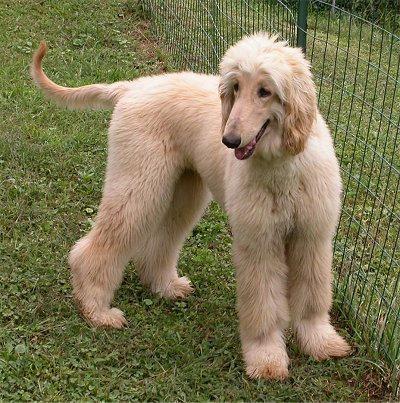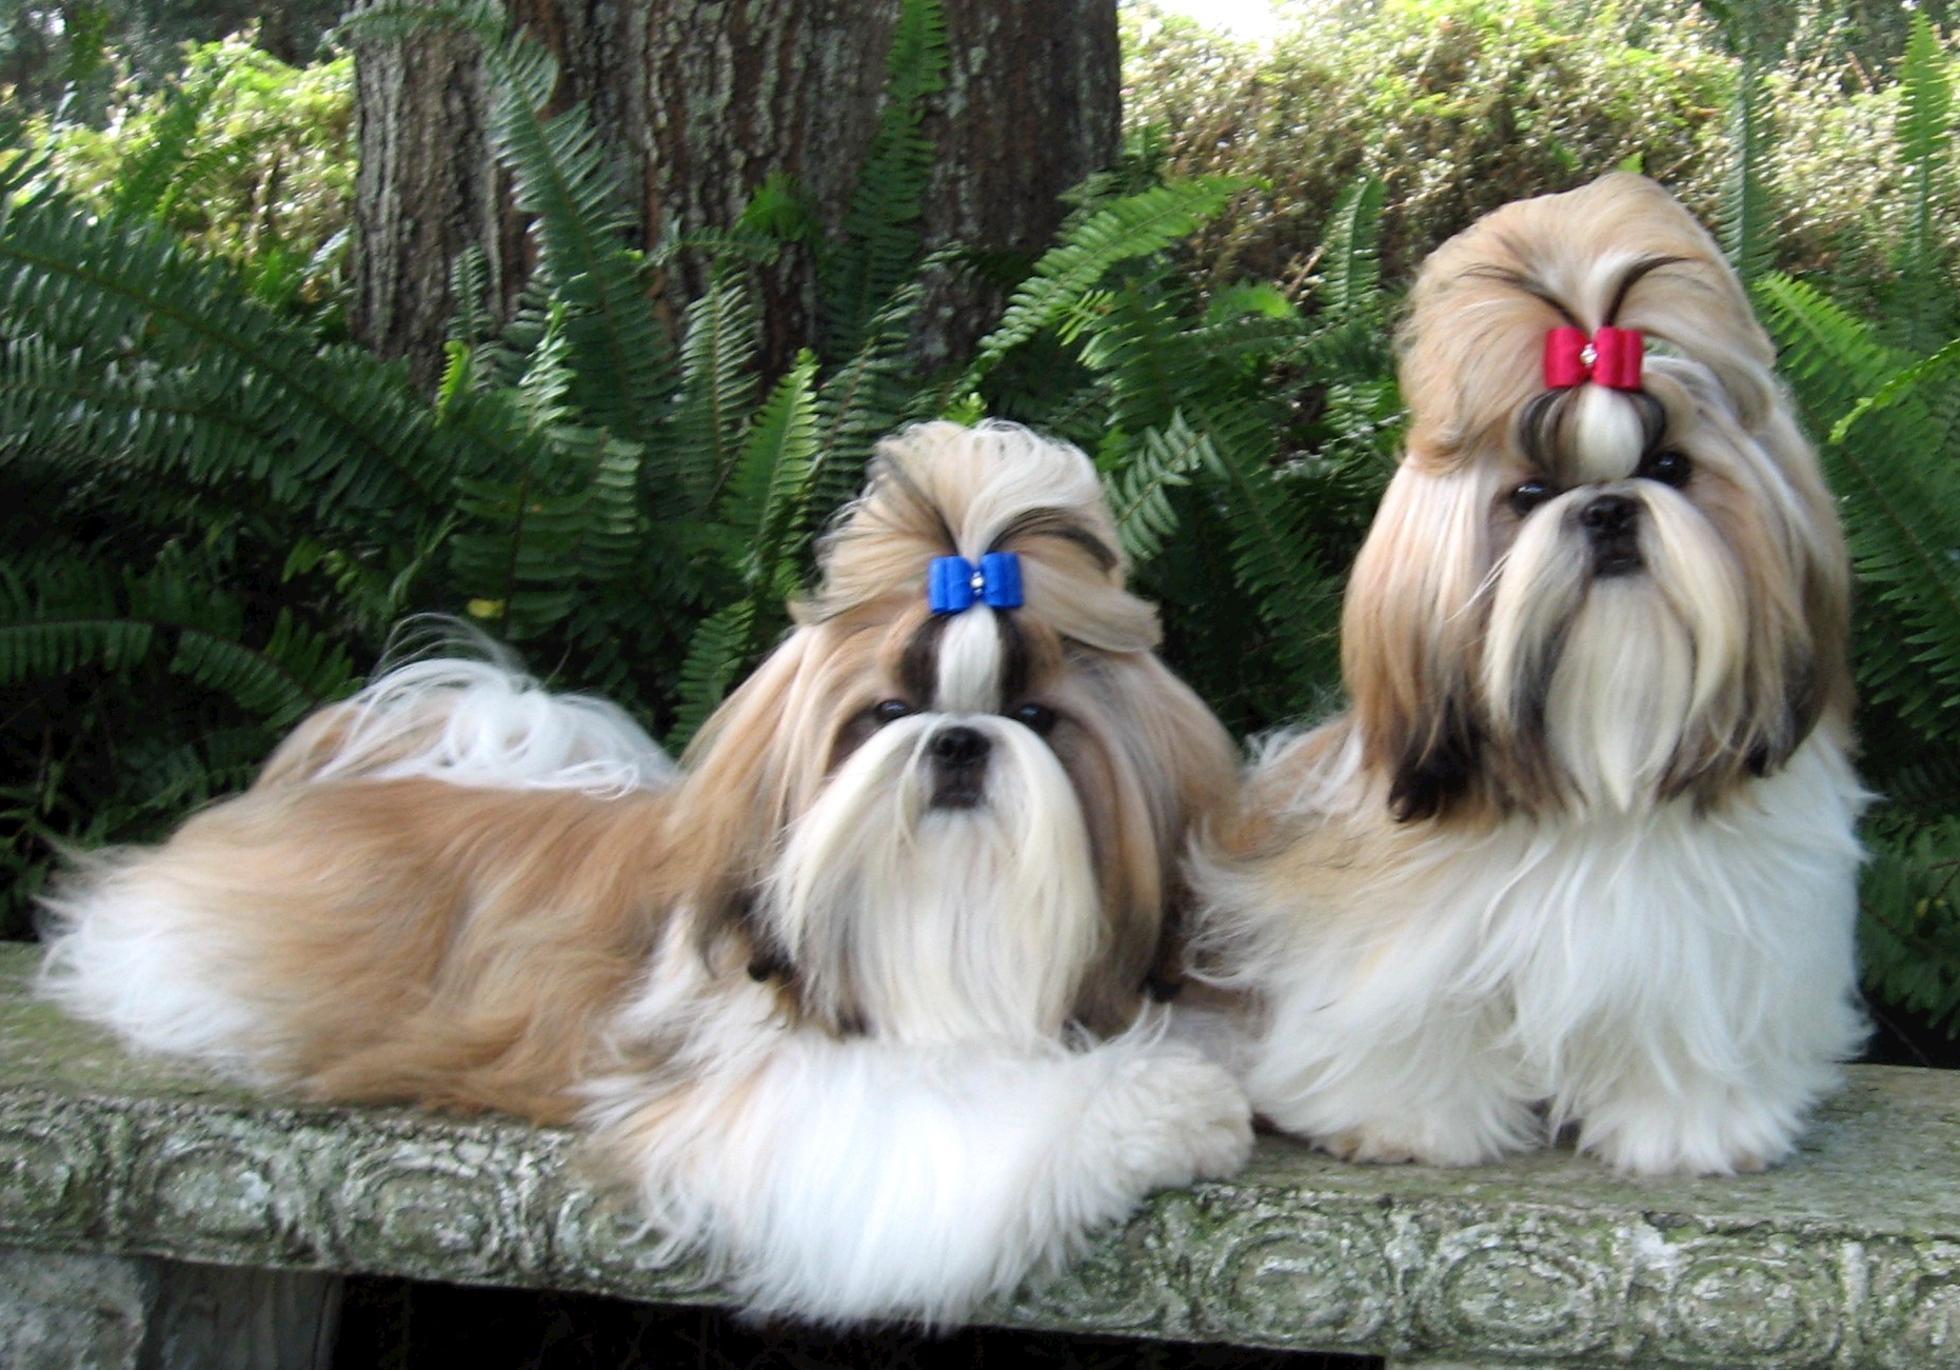The first image is the image on the left, the second image is the image on the right. Evaluate the accuracy of this statement regarding the images: "Only the dog in the left image is standing on all fours.". Is it true? Answer yes or no. Yes. 